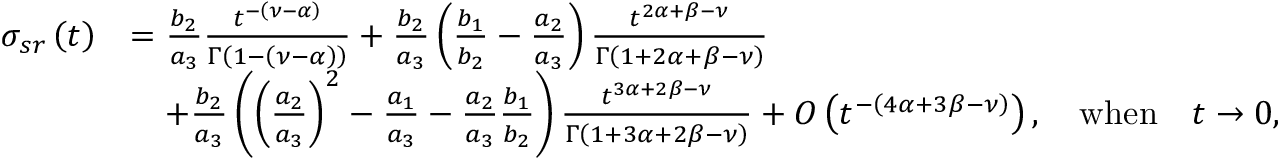<formula> <loc_0><loc_0><loc_500><loc_500>\begin{array} { r l } { \sigma _ { s r } \left ( t \right ) } & { = \frac { b _ { 2 } } { a _ { 3 } } \frac { t ^ { - \left ( \nu - \alpha \right ) } } { \Gamma \left ( 1 - \left ( \nu - \alpha \right ) \right ) } + \frac { b _ { 2 } } { a _ { 3 } } \left ( \frac { b _ { 1 } } { b _ { 2 } } - \frac { a _ { 2 } } { a _ { 3 } } \right ) \frac { t ^ { 2 \alpha + \beta - \nu } } { \Gamma \left ( 1 + 2 \alpha + \beta - \nu \right ) } } \\ & { \quad + \frac { b _ { 2 } } { a _ { 3 } } \left ( \left ( \frac { a _ { 2 } } { a _ { 3 } } \right ) ^ { 2 } - \frac { a _ { 1 } } { a _ { 3 } } - \frac { a _ { 2 } } { a _ { 3 } } \frac { b _ { 1 } } { b _ { 2 } } \right ) \frac { t ^ { 3 \alpha + 2 \beta - \nu } } { \Gamma \left ( 1 + 3 \alpha + 2 \beta - \nu \right ) } + O \left ( t ^ { - \left ( 4 \alpha + 3 \beta - \nu \right ) } \right ) , \quad w h e n \quad t \rightarrow 0 , } \end{array}</formula> 